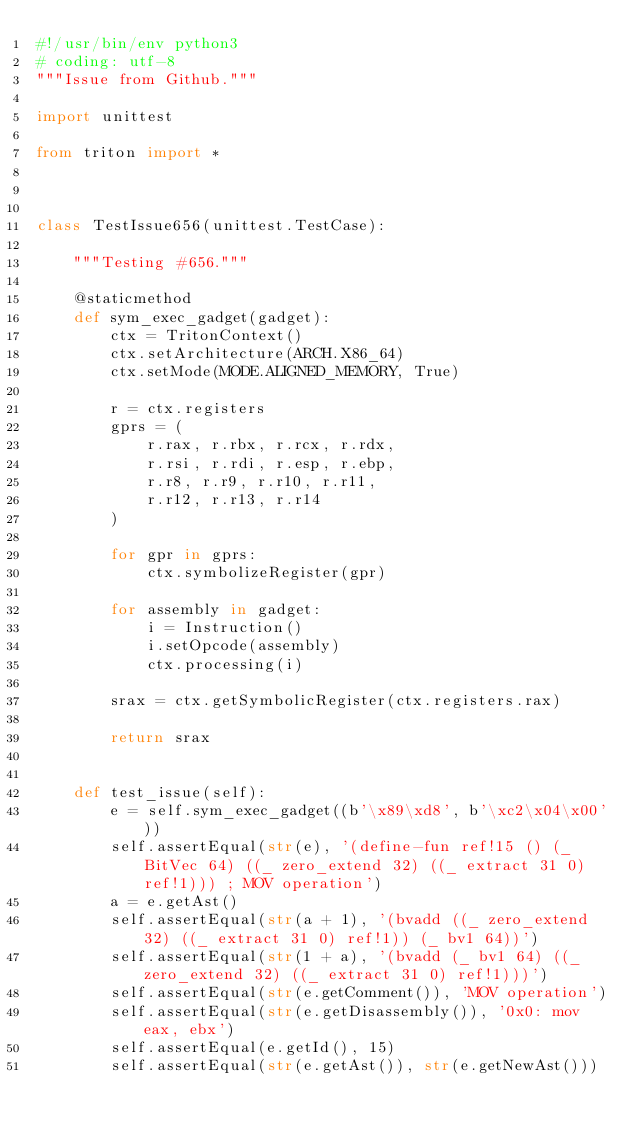Convert code to text. <code><loc_0><loc_0><loc_500><loc_500><_Python_>#!/usr/bin/env python3
# coding: utf-8
"""Issue from Github."""

import unittest

from triton import *



class TestIssue656(unittest.TestCase):

    """Testing #656."""

    @staticmethod
    def sym_exec_gadget(gadget):
        ctx = TritonContext()
        ctx.setArchitecture(ARCH.X86_64)
        ctx.setMode(MODE.ALIGNED_MEMORY, True)

        r = ctx.registers
        gprs = (
            r.rax, r.rbx, r.rcx, r.rdx,
            r.rsi, r.rdi, r.esp, r.ebp,
            r.r8, r.r9, r.r10, r.r11,
            r.r12, r.r13, r.r14
        )

        for gpr in gprs:
            ctx.symbolizeRegister(gpr)

        for assembly in gadget:
            i = Instruction()
            i.setOpcode(assembly)
            ctx.processing(i)

        srax = ctx.getSymbolicRegister(ctx.registers.rax)

        return srax


    def test_issue(self):
        e = self.sym_exec_gadget((b'\x89\xd8', b'\xc2\x04\x00'))
        self.assertEqual(str(e), '(define-fun ref!15 () (_ BitVec 64) ((_ zero_extend 32) ((_ extract 31 0) ref!1))) ; MOV operation')
        a = e.getAst()
        self.assertEqual(str(a + 1), '(bvadd ((_ zero_extend 32) ((_ extract 31 0) ref!1)) (_ bv1 64))')
        self.assertEqual(str(1 + a), '(bvadd (_ bv1 64) ((_ zero_extend 32) ((_ extract 31 0) ref!1)))')
        self.assertEqual(str(e.getComment()), 'MOV operation')
        self.assertEqual(str(e.getDisassembly()), '0x0: mov eax, ebx')
        self.assertEqual(e.getId(), 15)
        self.assertEqual(str(e.getAst()), str(e.getNewAst()))</code> 